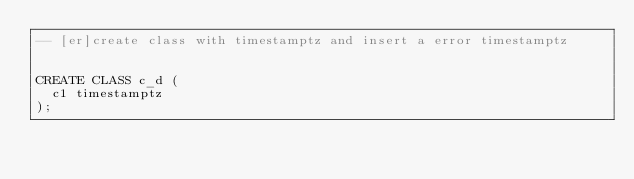Convert code to text. <code><loc_0><loc_0><loc_500><loc_500><_SQL_>-- [er]create class with timestamptz and insert a error timestamptz


CREATE CLASS c_d (
  c1 timestamptz
);
</code> 